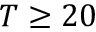Convert formula to latex. <formula><loc_0><loc_0><loc_500><loc_500>T \geq 2 0</formula> 